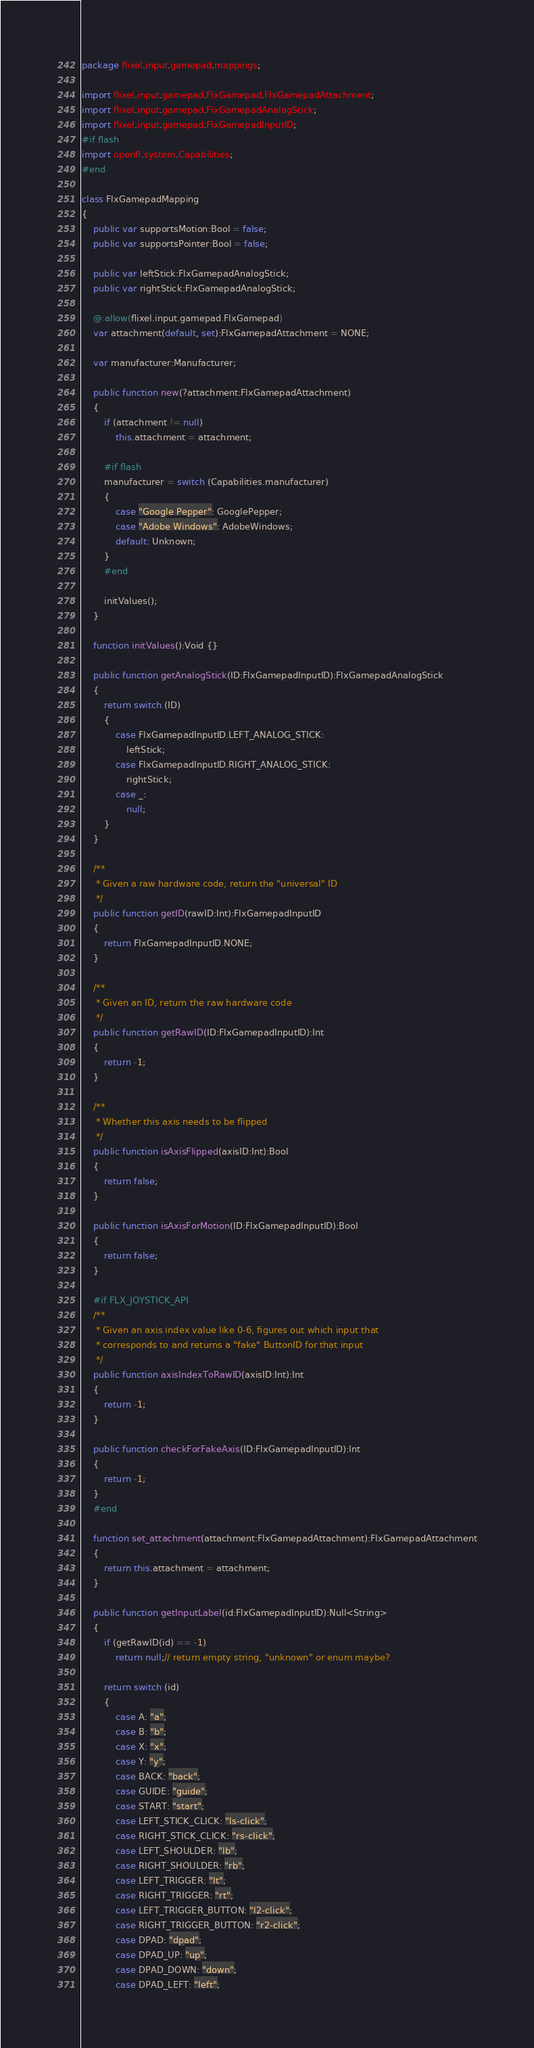Convert code to text. <code><loc_0><loc_0><loc_500><loc_500><_Haxe_>package flixel.input.gamepad.mappings;

import flixel.input.gamepad.FlxGamepad.FlxGamepadAttachment;
import flixel.input.gamepad.FlxGamepadAnalogStick;
import flixel.input.gamepad.FlxGamepadInputID;
#if flash
import openfl.system.Capabilities;
#end

class FlxGamepadMapping
{
	public var supportsMotion:Bool = false;
	public var supportsPointer:Bool = false;

	public var leftStick:FlxGamepadAnalogStick;
	public var rightStick:FlxGamepadAnalogStick;

	@:allow(flixel.input.gamepad.FlxGamepad)
	var attachment(default, set):FlxGamepadAttachment = NONE;

	var manufacturer:Manufacturer;

	public function new(?attachment:FlxGamepadAttachment)
	{
		if (attachment != null)
			this.attachment = attachment;

		#if flash
		manufacturer = switch (Capabilities.manufacturer)
		{
			case "Google Pepper": GooglePepper;
			case "Adobe Windows": AdobeWindows;
			default: Unknown;
		}
		#end

		initValues();
	}

	function initValues():Void {}

	public function getAnalogStick(ID:FlxGamepadInputID):FlxGamepadAnalogStick
	{
		return switch (ID)
		{
			case FlxGamepadInputID.LEFT_ANALOG_STICK:
				leftStick;
			case FlxGamepadInputID.RIGHT_ANALOG_STICK:
				rightStick;
			case _:
				null;
		}
	}

	/**
	 * Given a raw hardware code, return the "universal" ID
	 */
	public function getID(rawID:Int):FlxGamepadInputID
	{
		return FlxGamepadInputID.NONE;
	}

	/**
	 * Given an ID, return the raw hardware code
	 */
	public function getRawID(ID:FlxGamepadInputID):Int
	{
		return -1;
	}

	/**
	 * Whether this axis needs to be flipped
	 */
	public function isAxisFlipped(axisID:Int):Bool
	{
		return false;
	}

	public function isAxisForMotion(ID:FlxGamepadInputID):Bool
	{
		return false;
	}

	#if FLX_JOYSTICK_API
	/**
	 * Given an axis index value like 0-6, figures out which input that
	 * corresponds to and returns a "fake" ButtonID for that input
	 */
	public function axisIndexToRawID(axisID:Int):Int
	{
		return -1;
	}

	public function checkForFakeAxis(ID:FlxGamepadInputID):Int
	{
		return -1;
	}
	#end

	function set_attachment(attachment:FlxGamepadAttachment):FlxGamepadAttachment
	{
		return this.attachment = attachment;
	}
	
	public function getInputLabel(id:FlxGamepadInputID):Null<String>
	{
		if (getRawID(id) == -1)
			return null;// return empty string, "unknown" or enum maybe?
		
		return switch (id)
		{
			case A: "a";
			case B: "b";
			case X: "x";
			case Y: "y";
			case BACK: "back";
			case GUIDE: "guide";
			case START: "start";
			case LEFT_STICK_CLICK: "ls-click";
			case RIGHT_STICK_CLICK: "rs-click";
			case LEFT_SHOULDER: "lb";
			case RIGHT_SHOULDER: "rb";
			case LEFT_TRIGGER: "lt";
			case RIGHT_TRIGGER: "rt";
			case LEFT_TRIGGER_BUTTON: "l2-click";
			case RIGHT_TRIGGER_BUTTON: "r2-click";
			case DPAD: "dpad";
			case DPAD_UP: "up";
			case DPAD_DOWN: "down";
			case DPAD_LEFT: "left";</code> 